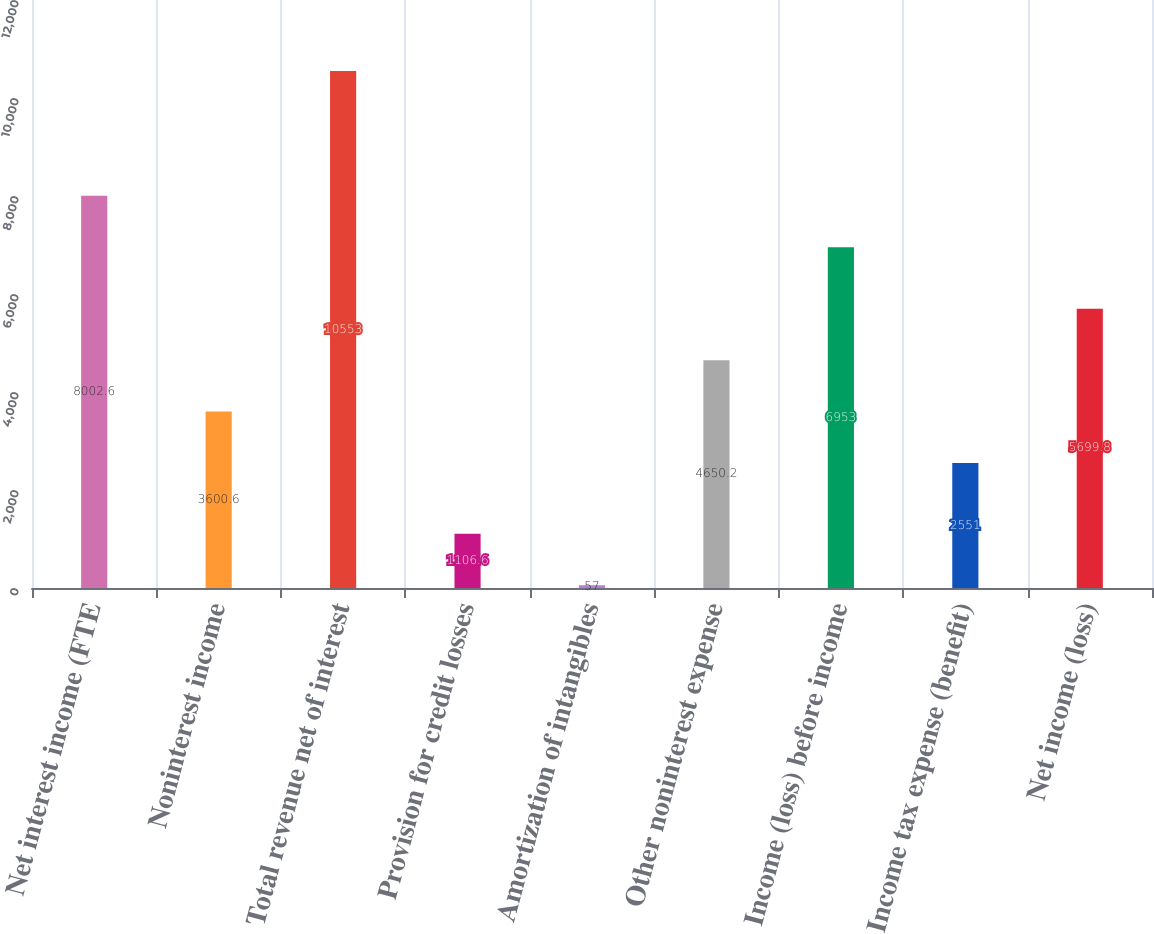Convert chart to OTSL. <chart><loc_0><loc_0><loc_500><loc_500><bar_chart><fcel>Net interest income (FTE<fcel>Noninterest income<fcel>Total revenue net of interest<fcel>Provision for credit losses<fcel>Amortization of intangibles<fcel>Other noninterest expense<fcel>Income (loss) before income<fcel>Income tax expense (benefit)<fcel>Net income (loss)<nl><fcel>8002.6<fcel>3600.6<fcel>10553<fcel>1106.6<fcel>57<fcel>4650.2<fcel>6953<fcel>2551<fcel>5699.8<nl></chart> 